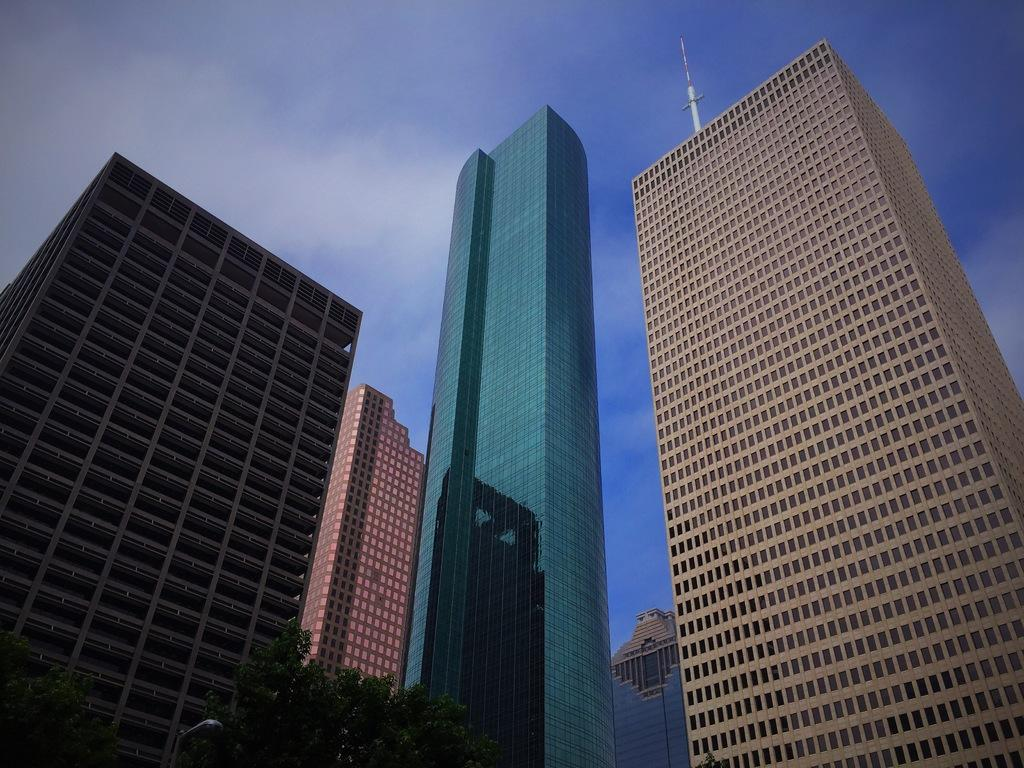What type of structures are depicted in the image? There are big buildings in the image. What feature can be seen on the buildings? There are glass doors on the buildings. What type of vegetation is visible at the bottom of the image? Trees are visible at the bottom of the image. What type of lighting is present in the image? A street light is present in the image. What object can be seen in the background of the image? There is a pole in the background of the image. What is visible in the sky in the background of the image? Clouds are visible in the sky in the background of the image. What type of suit is the passenger wearing in the image? There is no passenger present in the image, and therefore no suit can be observed. What type of art is displayed on the buildings in the image? There is no art displayed on the buildings in the image; the focus is on the buildings' structure and glass doors. 